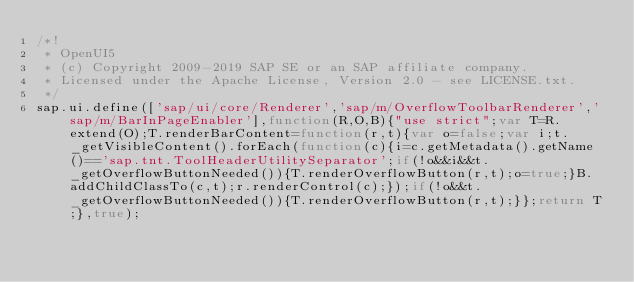<code> <loc_0><loc_0><loc_500><loc_500><_JavaScript_>/*!
 * OpenUI5
 * (c) Copyright 2009-2019 SAP SE or an SAP affiliate company.
 * Licensed under the Apache License, Version 2.0 - see LICENSE.txt.
 */
sap.ui.define(['sap/ui/core/Renderer','sap/m/OverflowToolbarRenderer','sap/m/BarInPageEnabler'],function(R,O,B){"use strict";var T=R.extend(O);T.renderBarContent=function(r,t){var o=false;var i;t._getVisibleContent().forEach(function(c){i=c.getMetadata().getName()=='sap.tnt.ToolHeaderUtilitySeparator';if(!o&&i&&t._getOverflowButtonNeeded()){T.renderOverflowButton(r,t);o=true;}B.addChildClassTo(c,t);r.renderControl(c);});if(!o&&t._getOverflowButtonNeeded()){T.renderOverflowButton(r,t);}};return T;},true);
</code> 